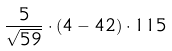Convert formula to latex. <formula><loc_0><loc_0><loc_500><loc_500>\frac { 5 } { \sqrt { 5 9 } } \cdot ( 4 - 4 2 ) \cdot 1 1 5</formula> 